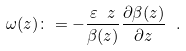<formula> <loc_0><loc_0><loc_500><loc_500>\omega ( z ) \colon = - \frac { \varepsilon \ z } { \beta ( z ) } \frac { \partial \beta ( z ) } { \partial z } \ .</formula> 